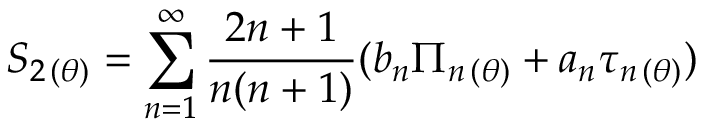Convert formula to latex. <formula><loc_0><loc_0><loc_500><loc_500>S _ { 2 \, ( \theta ) } = \sum _ { n = 1 } ^ { \infty } \frac { 2 n + 1 } { n ( n + 1 ) } ( b _ { n } \Pi _ { n \, ( \theta ) } + a _ { n } \tau _ { n \, ( \theta ) } )</formula> 